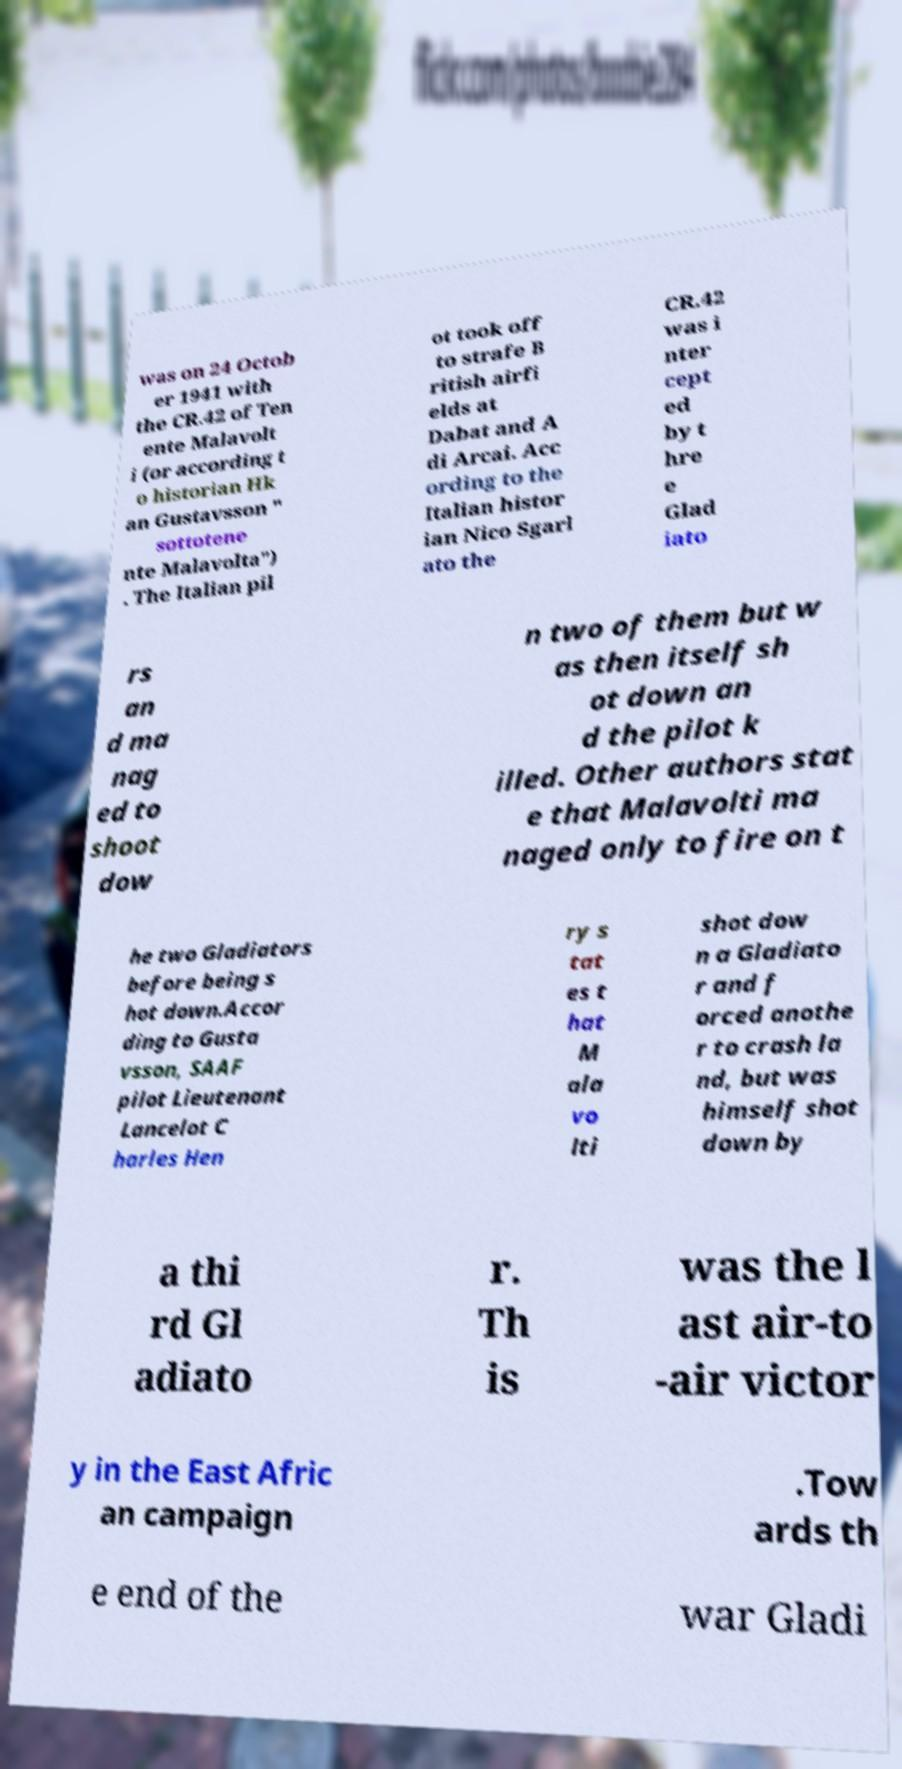There's text embedded in this image that I need extracted. Can you transcribe it verbatim? was on 24 Octob er 1941 with the CR.42 of Ten ente Malavolt i (or according t o historian Hk an Gustavsson " sottotene nte Malavolta") . The Italian pil ot took off to strafe B ritish airfi elds at Dabat and A di Arcai. Acc ording to the Italian histor ian Nico Sgarl ato the CR.42 was i nter cept ed by t hre e Glad iato rs an d ma nag ed to shoot dow n two of them but w as then itself sh ot down an d the pilot k illed. Other authors stat e that Malavolti ma naged only to fire on t he two Gladiators before being s hot down.Accor ding to Gusta vsson, SAAF pilot Lieutenant Lancelot C harles Hen ry s tat es t hat M ala vo lti shot dow n a Gladiato r and f orced anothe r to crash la nd, but was himself shot down by a thi rd Gl adiato r. Th is was the l ast air-to -air victor y in the East Afric an campaign .Tow ards th e end of the war Gladi 